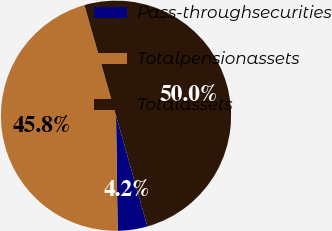<chart> <loc_0><loc_0><loc_500><loc_500><pie_chart><fcel>Pass-throughsecurities<fcel>Totalpensionassets<fcel>Totalassets<nl><fcel>4.18%<fcel>45.8%<fcel>50.02%<nl></chart> 